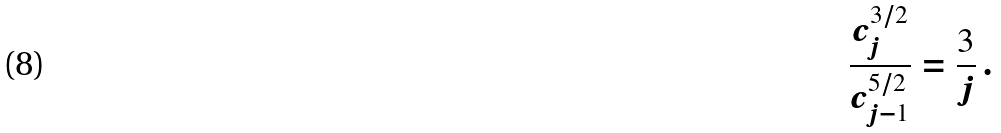<formula> <loc_0><loc_0><loc_500><loc_500>\frac { c ^ { 3 / 2 } _ { j } } { c ^ { 5 / 2 } _ { j - 1 } } = \frac { 3 } { j } \, .</formula> 